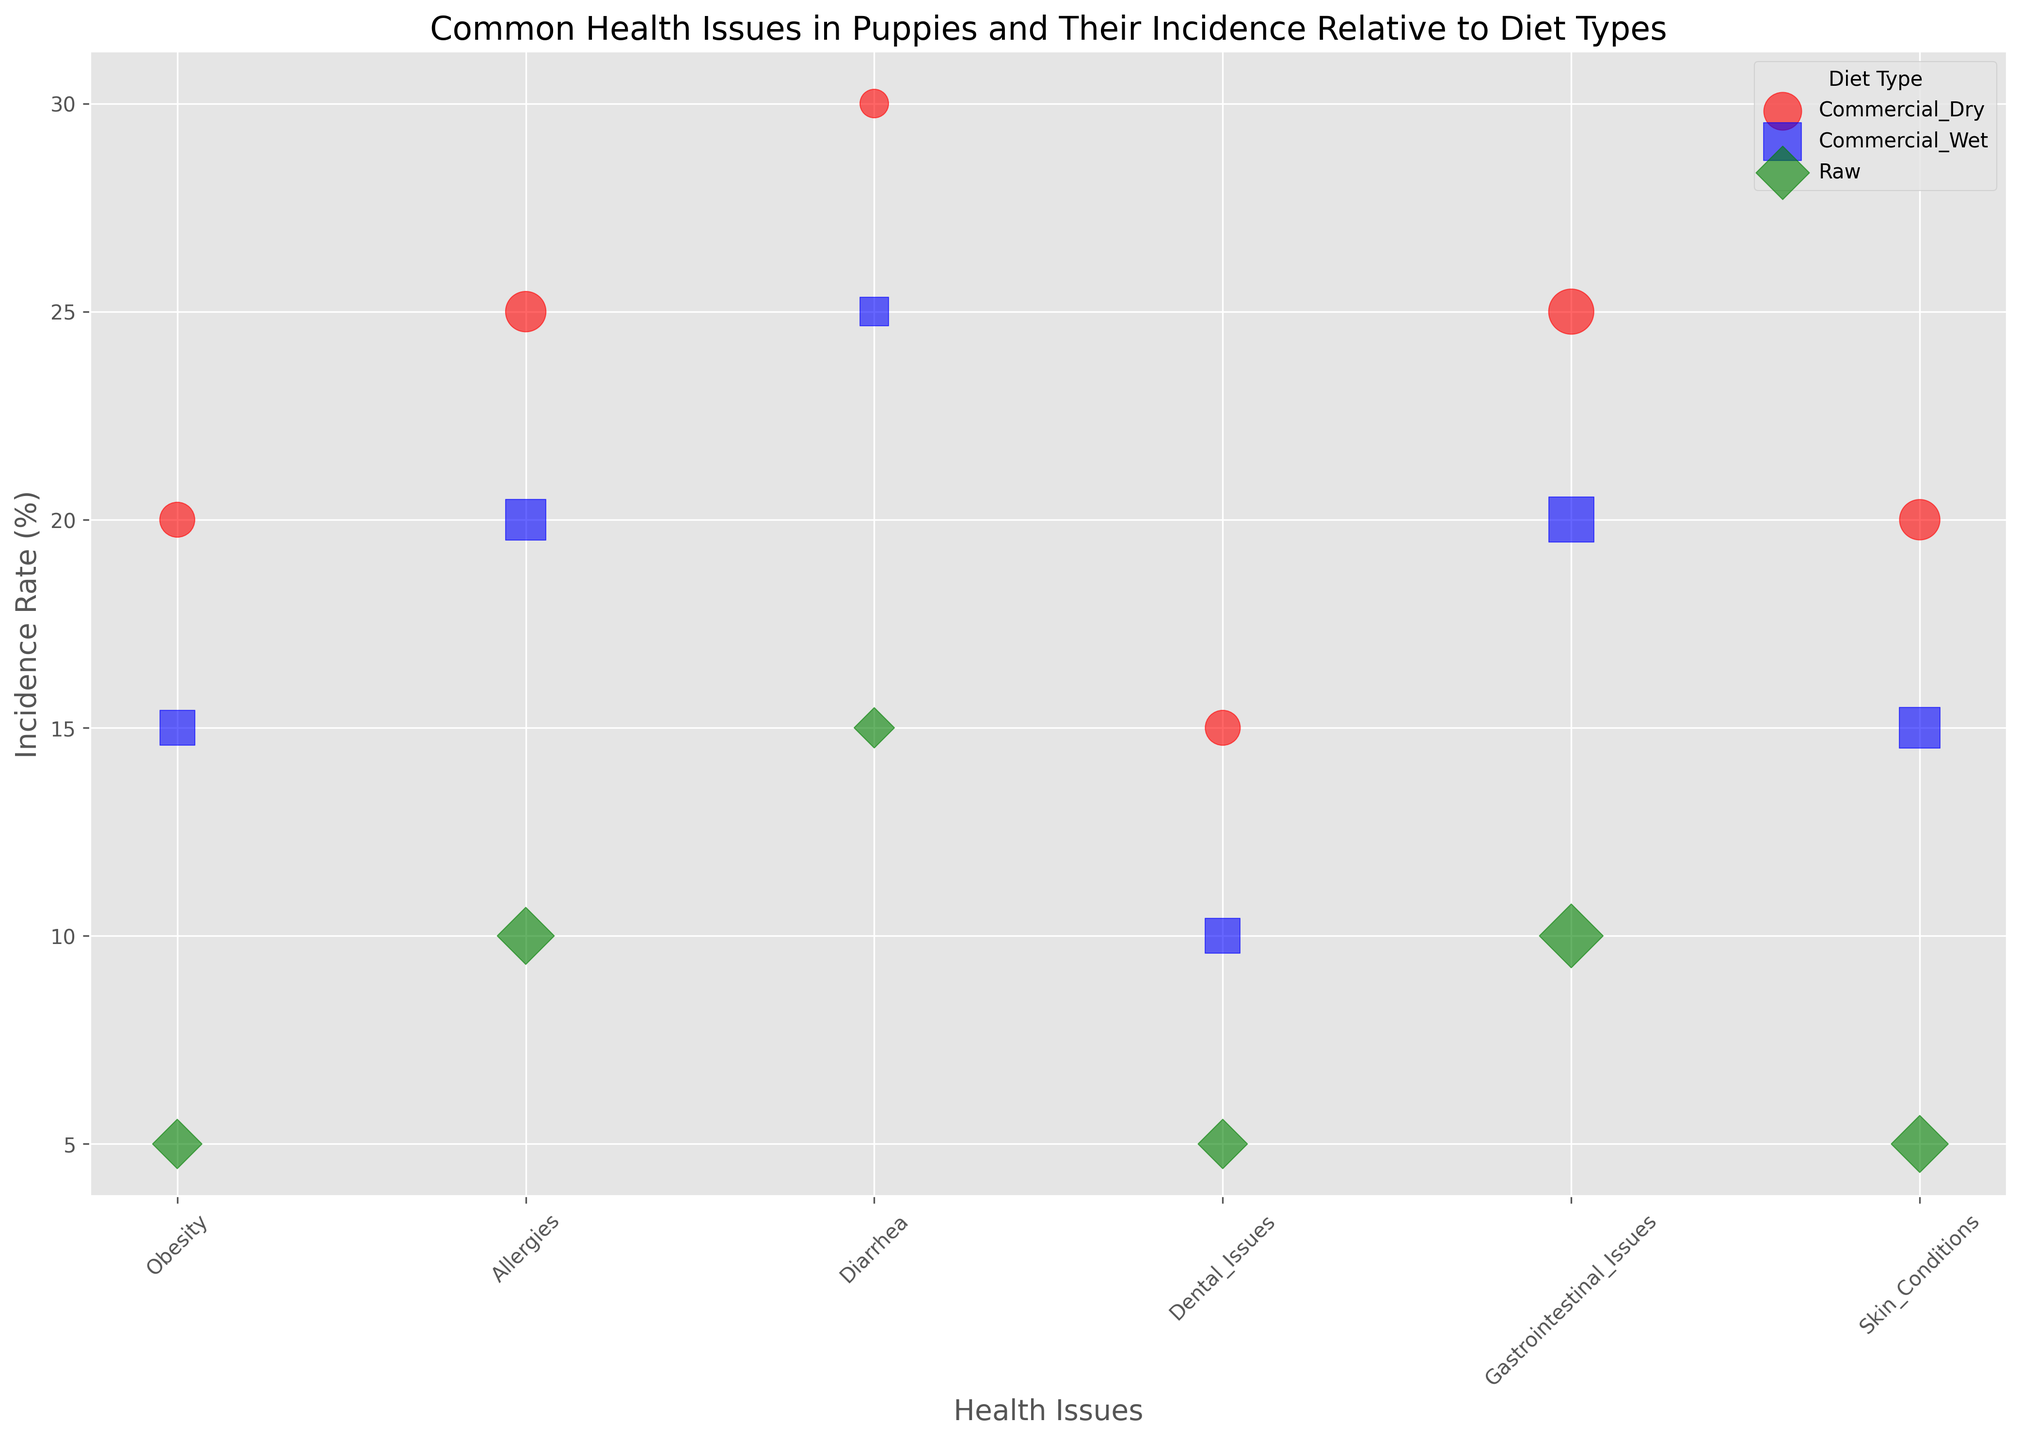How does the incidence rate of obesity compare between commercial wet and raw diets? By observing the y-values corresponding to the bubbles for obesity associated with Commercial_Wet and Raw diets, you can see that Commercial_Wet has an incidence rate of 15%, while Raw has 5%.
Answer: Commercial_Wet: 15%, Raw: 5% Which health issue has the highest incidence rate in puppies fed a commercial dry diet? Look at the y-values for the different health issues associated with the Commercial_Dry diet. The highest y-value is 30%, which corresponds to Diarrhea.
Answer: Diarrhea What is the total severity scale for allergies across all diet types? Find the severity scale values for allergies in all three diet types. They are 4 for each type. Summing these values: 4 + 4 + 4 = 12.
Answer: 12 Which diet type has the least severe gastrointestinal issues based on the bubble size? Compare the size of bubbles for gastrointestinal issues across all diet types. The Raw diet has the smallest bubble size, indicating a severity scale of 5, which is the same for all diet types, but it appears less prominent due to visualization.
Answer: Raw What is the incidence rate color of skin conditions in puppies fed a commercial wet diet? Identify the color associated with the bubble for skin conditions and the commercial wet diet. The color is blue.
Answer: Blue Between commercial dry and raw diets, which has a higher incidence rate for dental issues, and by how much? Look at the y-values for dental issues related to Commercial_Dry and Raw diets. The Commercial_Dry diet has an incidence rate of 15%, while the Raw diet has 5%. Subtract the lower from the higher: 15% - 5% = 10%.
Answer: Commercial_Dry by 10% What is the average incidence rate of obesity across all diet types? Find the incidence rates of obesity for all diet types: 20%, 15%, and 5%. Sum these values and divide by the number of diet types: (20 + 15 + 5) / 3 = 13.33%.
Answer: 13.33% Compare the severity of allergies and gastrointestinal issues in puppies fed a raw diet. Look at the severity scale for allergies and gastrointestinal issues for the Raw diet. Both have a severity scale of 4 and 5 respectively.
Answer: Allergies: 4, Gastrointestinal_Issues: 5 